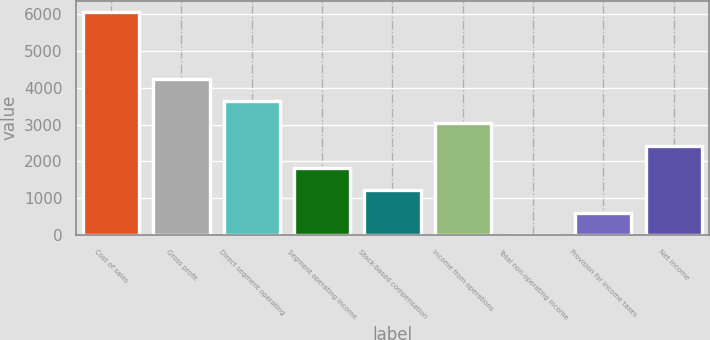Convert chart to OTSL. <chart><loc_0><loc_0><loc_500><loc_500><bar_chart><fcel>Cost of sales<fcel>Gross profit<fcel>Direct segment operating<fcel>Segment operating income<fcel>Stock-based compensation<fcel>Income from operations<fcel>Total non-operating income<fcel>Provision for income taxes<fcel>Net income<nl><fcel>6064<fcel>4246.3<fcel>3640.4<fcel>1822.7<fcel>1216.8<fcel>3034.5<fcel>5<fcel>610.9<fcel>2428.6<nl></chart> 